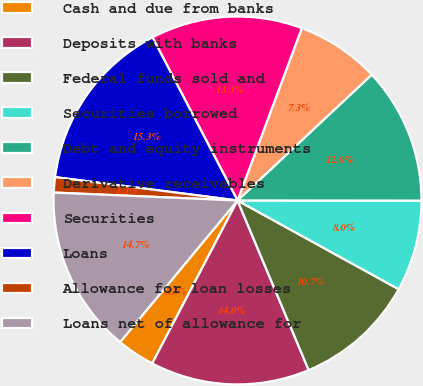Convert chart. <chart><loc_0><loc_0><loc_500><loc_500><pie_chart><fcel>Cash and due from banks<fcel>Deposits with banks<fcel>Federal funds sold and<fcel>Securities borrowed<fcel>Debt and equity instruments<fcel>Derivative receivables<fcel>Securities<fcel>Loans<fcel>Allowance for loan losses<fcel>Loans net of allowance for<nl><fcel>3.34%<fcel>14.0%<fcel>10.67%<fcel>8.0%<fcel>12.0%<fcel>7.33%<fcel>13.33%<fcel>15.33%<fcel>1.34%<fcel>14.67%<nl></chart> 